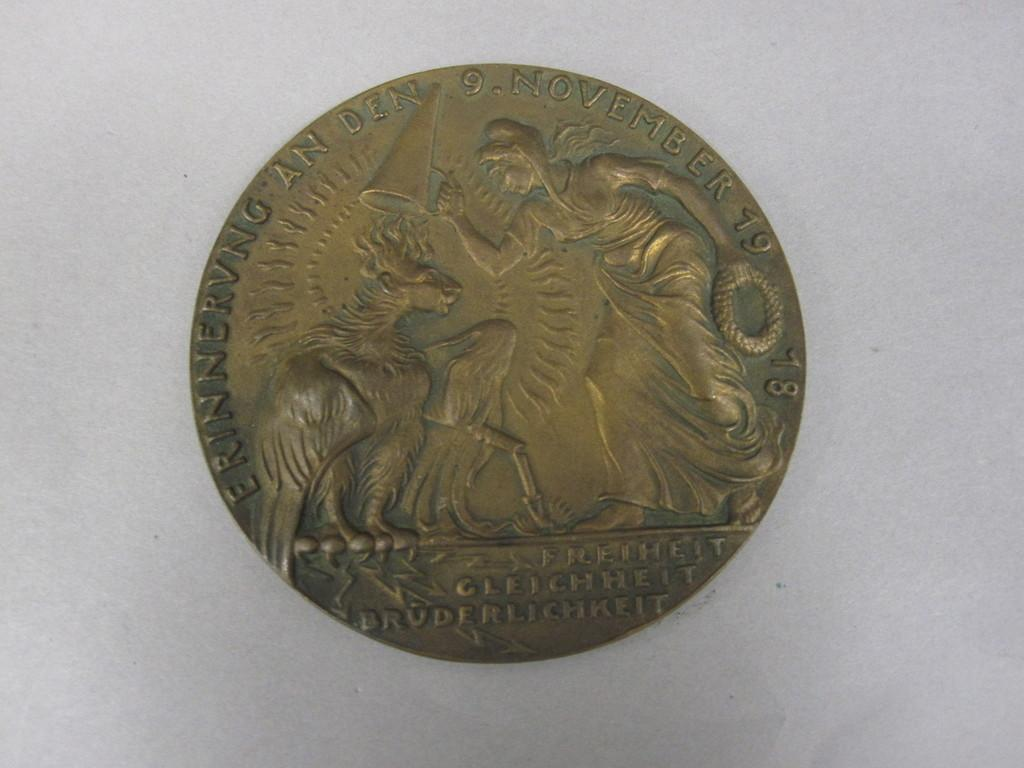What is the main subject of the image? The main subject of the image is a coin. Can you describe the location of the coin in the image? The coin is in the center of the image. What type of instrument is being played by the achiever in the image? There is no instrument or achiever present in the image; it only features a coin. 